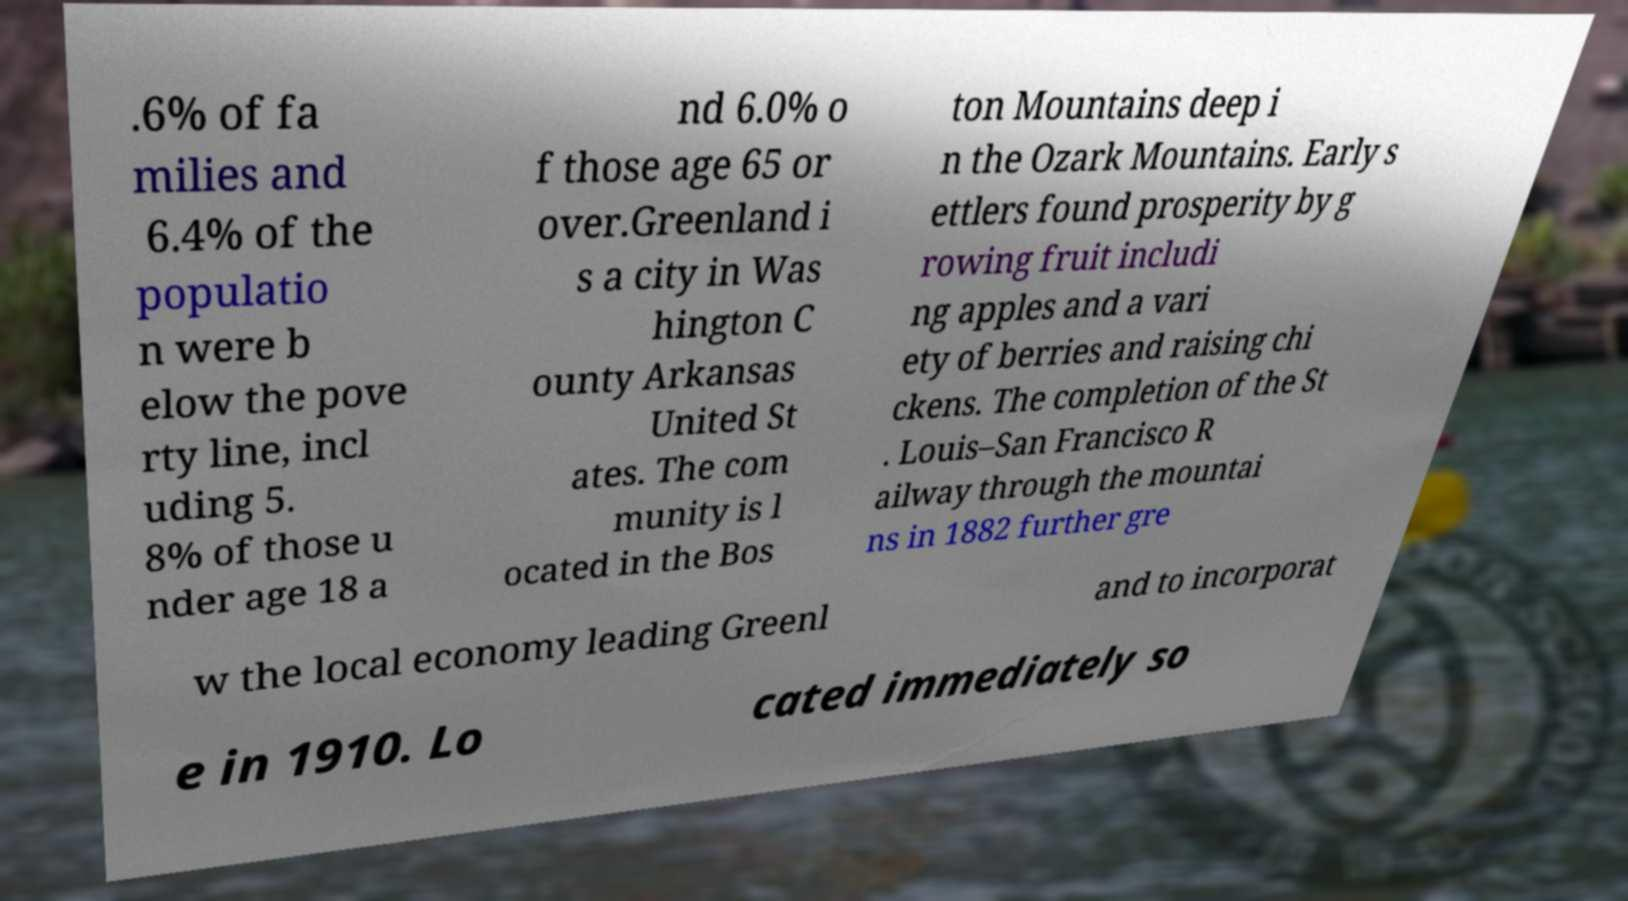What messages or text are displayed in this image? I need them in a readable, typed format. .6% of fa milies and 6.4% of the populatio n were b elow the pove rty line, incl uding 5. 8% of those u nder age 18 a nd 6.0% o f those age 65 or over.Greenland i s a city in Was hington C ounty Arkansas United St ates. The com munity is l ocated in the Bos ton Mountains deep i n the Ozark Mountains. Early s ettlers found prosperity by g rowing fruit includi ng apples and a vari ety of berries and raising chi ckens. The completion of the St . Louis–San Francisco R ailway through the mountai ns in 1882 further gre w the local economy leading Greenl and to incorporat e in 1910. Lo cated immediately so 